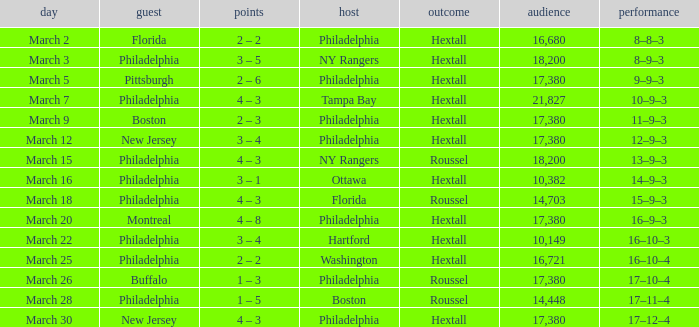Date of march 30 involves what home? Philadelphia. 